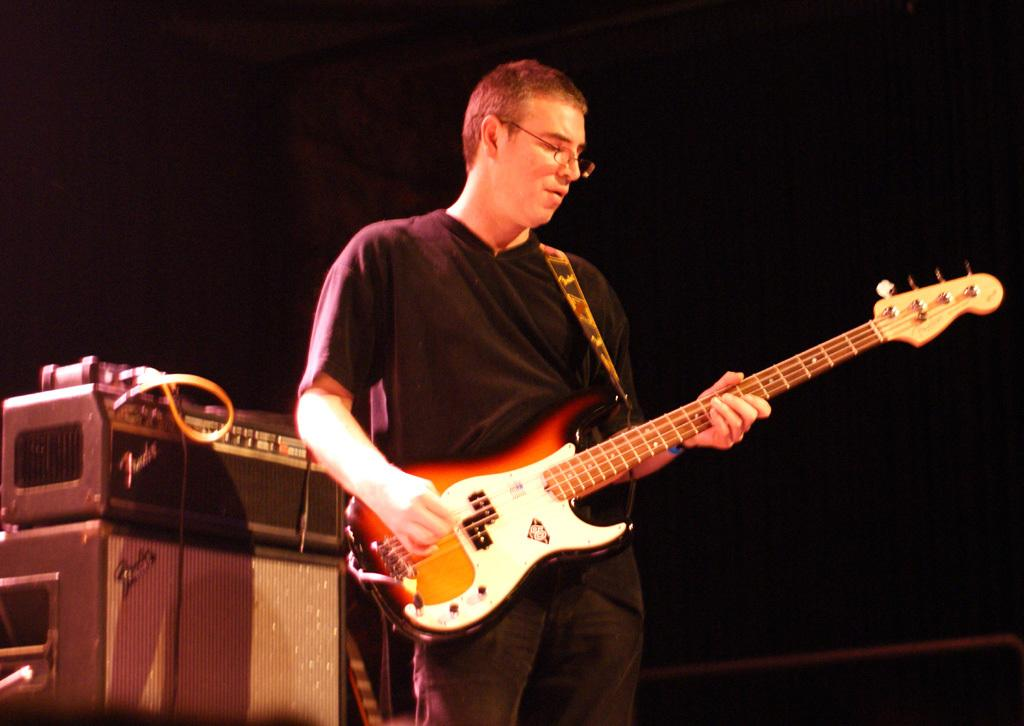What is the man in the image doing? The man is playing the guitar. What object is the man holding in the image? The man is holding a guitar. What can be seen in the image besides the man and the guitar? There are speakers and a machine in the image. How would you describe the lighting in the image? The background of the image is dark. How many people are participating in the mass in the image? There is no mass present in the image. 